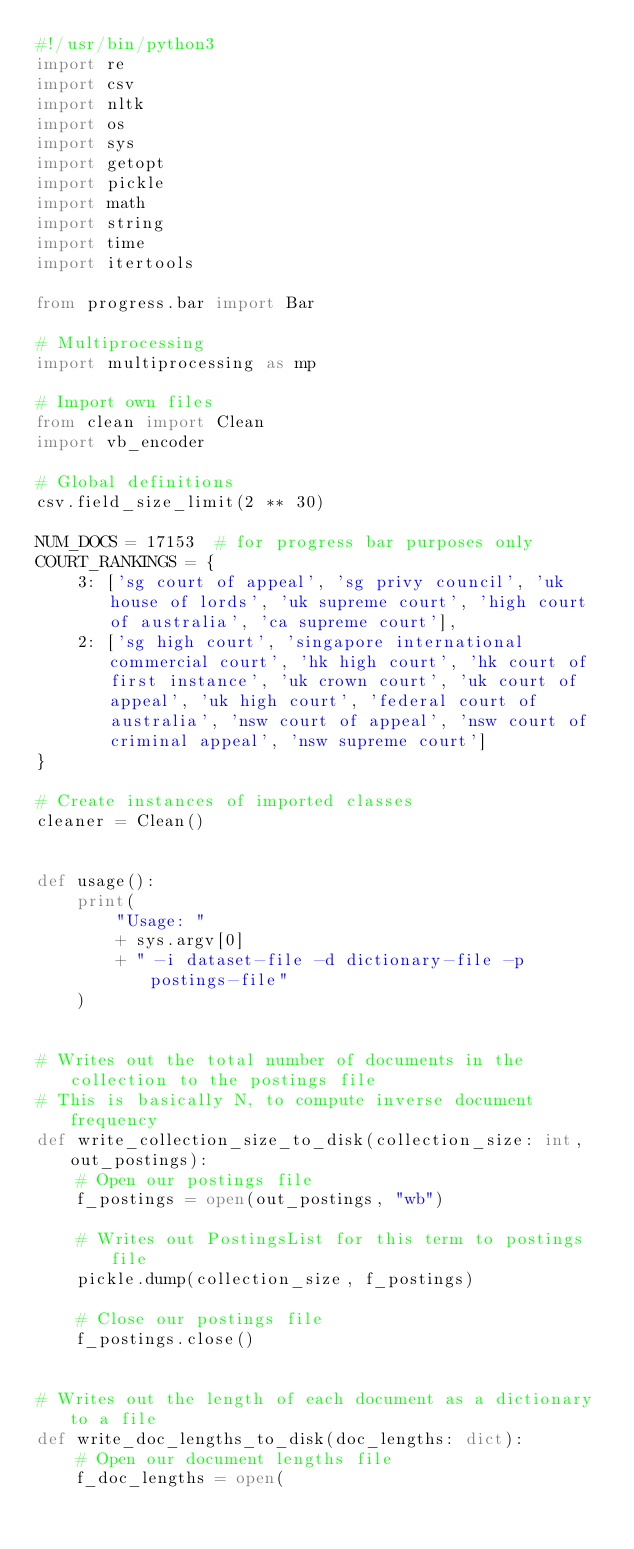<code> <loc_0><loc_0><loc_500><loc_500><_Python_>#!/usr/bin/python3
import re
import csv
import nltk
import os
import sys
import getopt
import pickle
import math
import string
import time
import itertools

from progress.bar import Bar

# Multiprocessing
import multiprocessing as mp

# Import own files
from clean import Clean
import vb_encoder

# Global definitions
csv.field_size_limit(2 ** 30)

NUM_DOCS = 17153  # for progress bar purposes only
COURT_RANKINGS = {
    3: ['sg court of appeal', 'sg privy council', 'uk house of lords', 'uk supreme court', 'high court of australia', 'ca supreme court'],
    2: ['sg high court', 'singapore international commercial court', 'hk high court', 'hk court of first instance', 'uk crown court', 'uk court of appeal', 'uk high court', 'federal court of australia', 'nsw court of appeal', 'nsw court of criminal appeal', 'nsw supreme court']
}

# Create instances of imported classes
cleaner = Clean()


def usage():
    print(
        "Usage: "
        + sys.argv[0]
        + " -i dataset-file -d dictionary-file -p postings-file"
    )


# Writes out the total number of documents in the collection to the postings file
# This is basically N, to compute inverse document frequency
def write_collection_size_to_disk(collection_size: int, out_postings):
    # Open our postings file
    f_postings = open(out_postings, "wb")

    # Writes out PostingsList for this term to postings file
    pickle.dump(collection_size, f_postings)

    # Close our postings file
    f_postings.close()


# Writes out the length of each document as a dictionary to a file
def write_doc_lengths_to_disk(doc_lengths: dict):
    # Open our document lengths file
    f_doc_lengths = open(</code> 